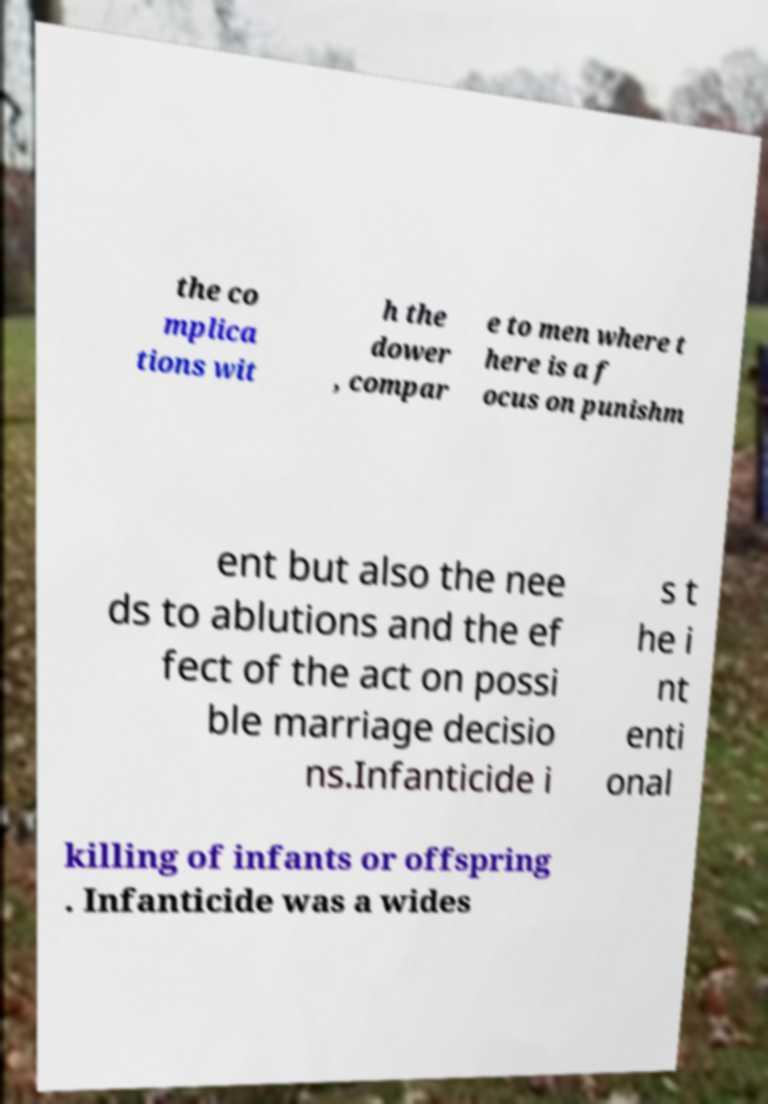For documentation purposes, I need the text within this image transcribed. Could you provide that? the co mplica tions wit h the dower , compar e to men where t here is a f ocus on punishm ent but also the nee ds to ablutions and the ef fect of the act on possi ble marriage decisio ns.Infanticide i s t he i nt enti onal killing of infants or offspring . Infanticide was a wides 